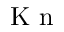<formula> <loc_0><loc_0><loc_500><loc_500>K n</formula> 